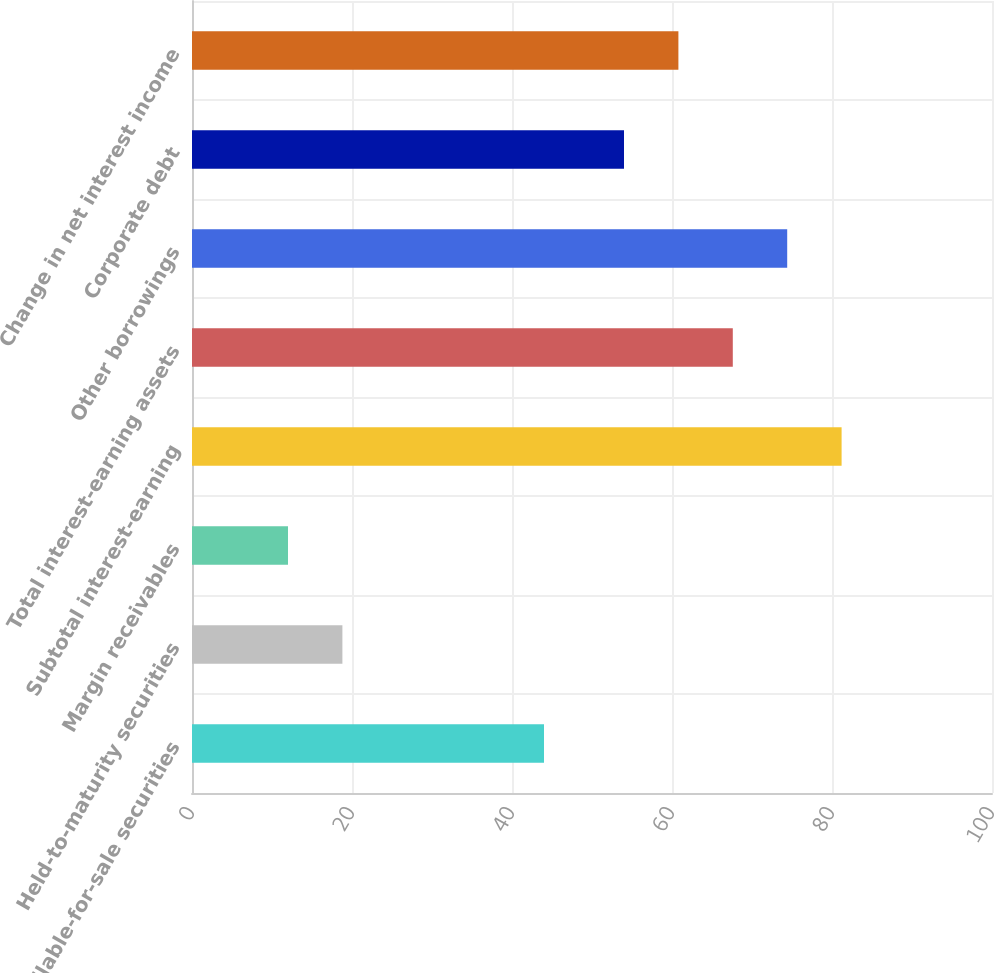Convert chart. <chart><loc_0><loc_0><loc_500><loc_500><bar_chart><fcel>Available-for-sale securities<fcel>Held-to-maturity securities<fcel>Margin receivables<fcel>Subtotal interest-earning<fcel>Total interest-earning assets<fcel>Other borrowings<fcel>Corporate debt<fcel>Change in net interest income<nl><fcel>44<fcel>18.8<fcel>12<fcel>81.2<fcel>67.6<fcel>74.4<fcel>54<fcel>60.8<nl></chart> 